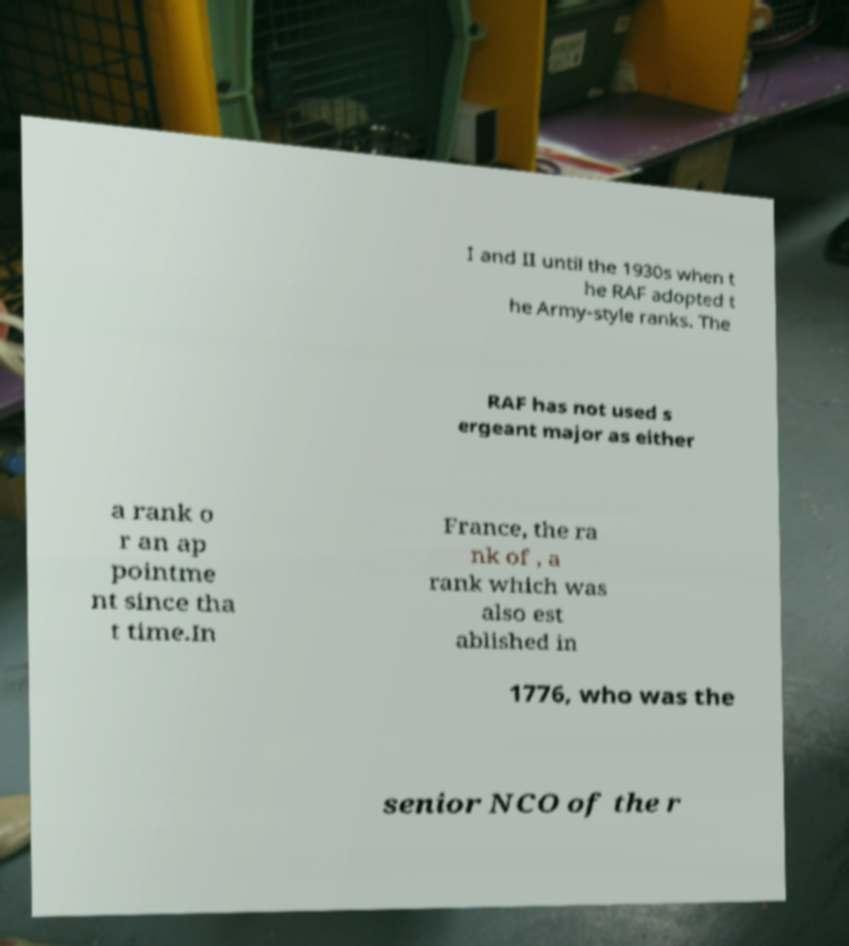I need the written content from this picture converted into text. Can you do that? I and II until the 1930s when t he RAF adopted t he Army-style ranks. The RAF has not used s ergeant major as either a rank o r an ap pointme nt since tha t time.In France, the ra nk of , a rank which was also est ablished in 1776, who was the senior NCO of the r 